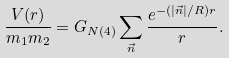<formula> <loc_0><loc_0><loc_500><loc_500>\frac { V ( r ) } { m _ { 1 } m _ { 2 } } = G _ { N ( 4 ) } \sum _ { \vec { n } } \frac { e ^ { { - ( | \vec { n } | } / { R } ) r } } { r } .</formula> 